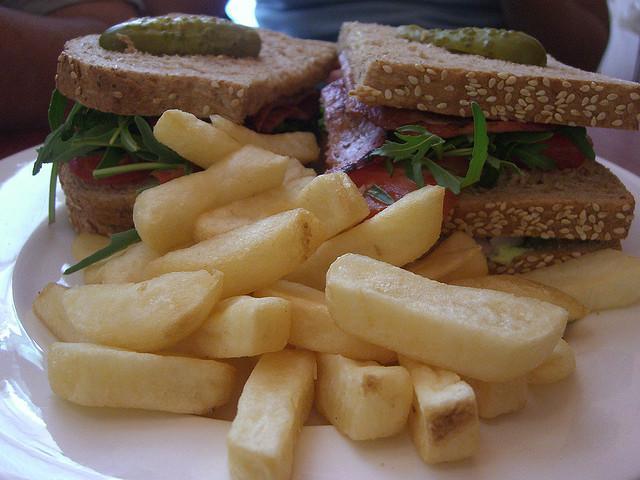Is the given caption "The apple is above the banana." fitting for the image?
Answer yes or no. No. Is the statement "The person is touching the apple." accurate regarding the image?
Answer yes or no. No. Does the image validate the caption "The apple is close to the banana."?
Answer yes or no. No. Is this affirmation: "The person is beside the apple." correct?
Answer yes or no. No. 